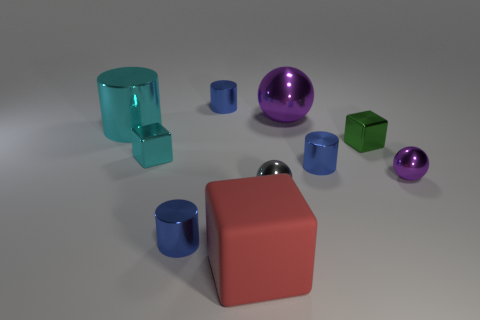The green shiny thing that is the same size as the gray object is what shape? cube 